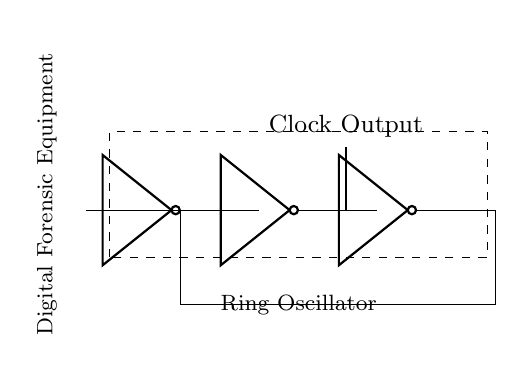What type of oscillator is represented in the circuit? The circuit is a ring oscillator, which is indicated by the feedback loop connecting the output of the last inverter back to the input of the first inverter.
Answer: Ring oscillator How many inverters are in the circuit? There are three inverters in the circuit, as shown by the three distinct "not port" symbols connected in series.
Answer: Three What signal is generated by this oscillator? The output of the oscillator is a clock signal, which is typically a square wave signal used in digital circuits. This is indicated by the node labeled "Clock Output."
Answer: Clock signal What is the general purpose of this ring oscillator in the context of digital forensic equipment? The ring oscillator serves to provide a clock signal necessary for the functioning of digital circuits within forensic equipment, enabling synchronization of operations and measurements.
Answer: Clock generation How is the feedback loop structured in this circuit? The feedback loop is formed by connecting the output of the last inverter back to the input of the first inverter, creating a circular path for the signal to propagate through the inverters.
Answer: Circular feedback loop What component is primarily used for signal inversion in this oscillator? The primary component for signal inversion in this circuit is the inverter, indicated by the "not port" symbols that are essential for oscillation.
Answer: Inverter 